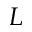Convert formula to latex. <formula><loc_0><loc_0><loc_500><loc_500>L</formula> 